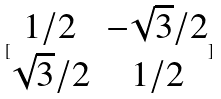Convert formula to latex. <formula><loc_0><loc_0><loc_500><loc_500>[ \begin{matrix} 1 / 2 & - \sqrt { 3 } / 2 \\ \sqrt { 3 } / 2 & 1 / 2 \end{matrix} ]</formula> 